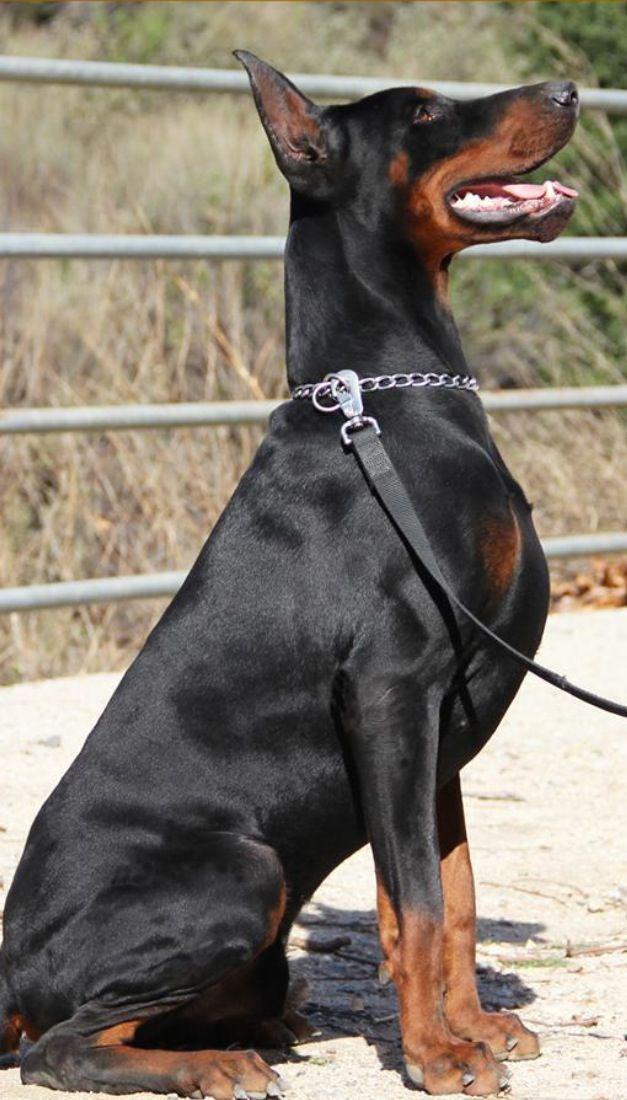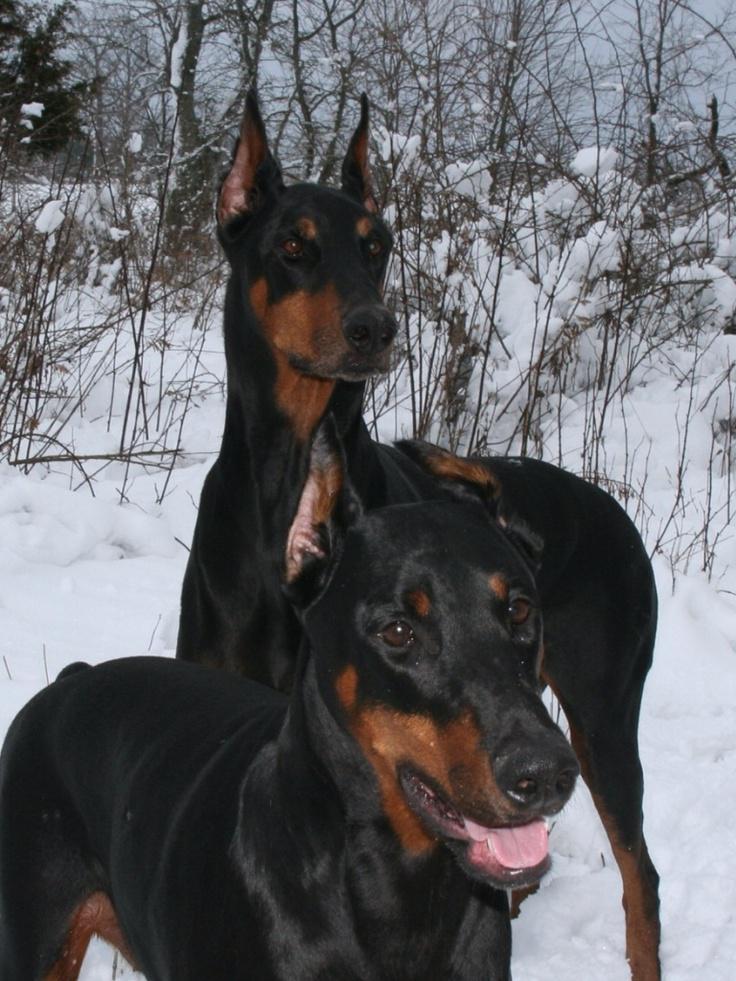The first image is the image on the left, the second image is the image on the right. For the images shown, is this caption "Two dogs are sleeping on a couch in the left image." true? Answer yes or no. No. The first image is the image on the left, the second image is the image on the right. Considering the images on both sides, is "Each image contains two dobermans, and the left image depicts dobermans reclining on a sofa." valid? Answer yes or no. No. 